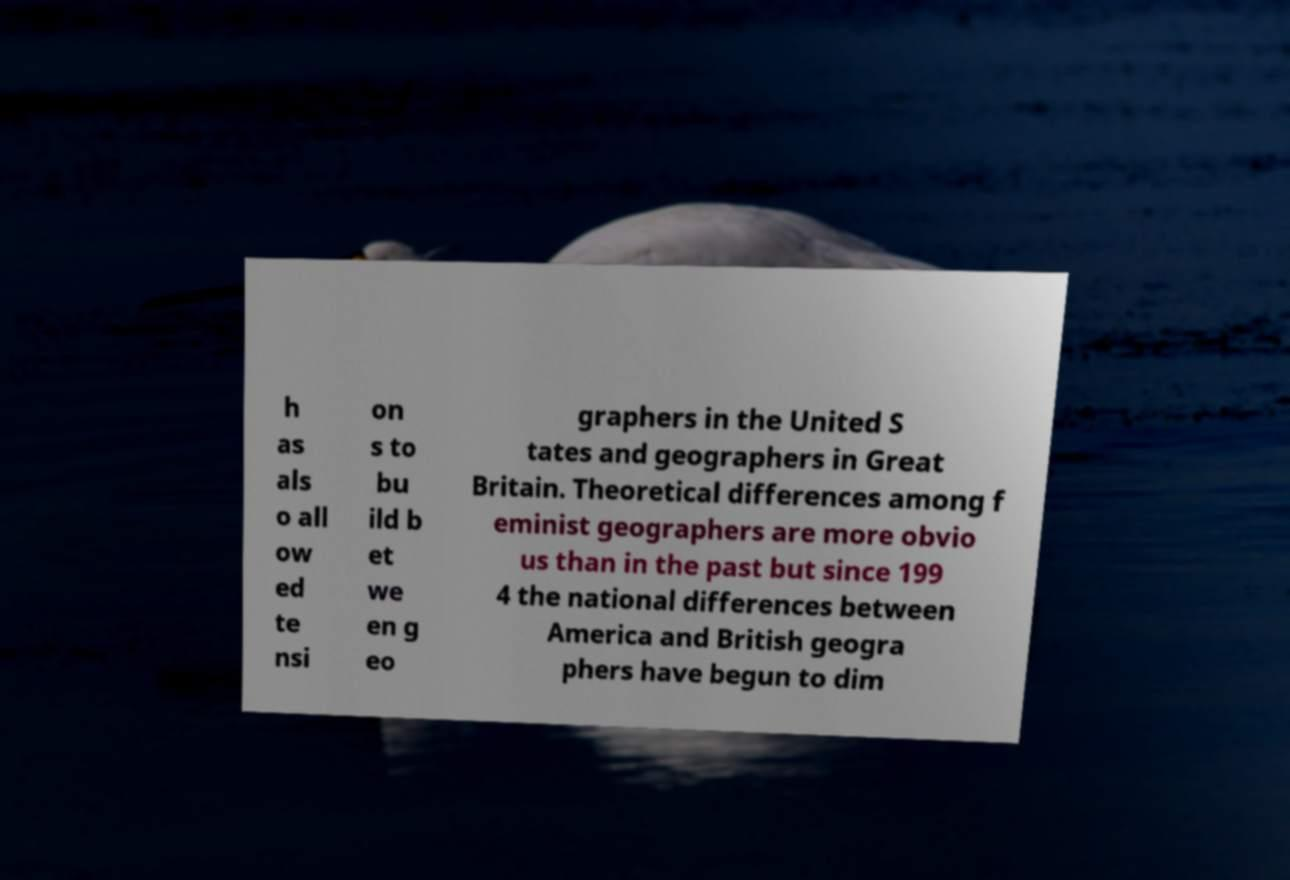I need the written content from this picture converted into text. Can you do that? h as als o all ow ed te nsi on s to bu ild b et we en g eo graphers in the United S tates and geographers in Great Britain. Theoretical differences among f eminist geographers are more obvio us than in the past but since 199 4 the national differences between America and British geogra phers have begun to dim 